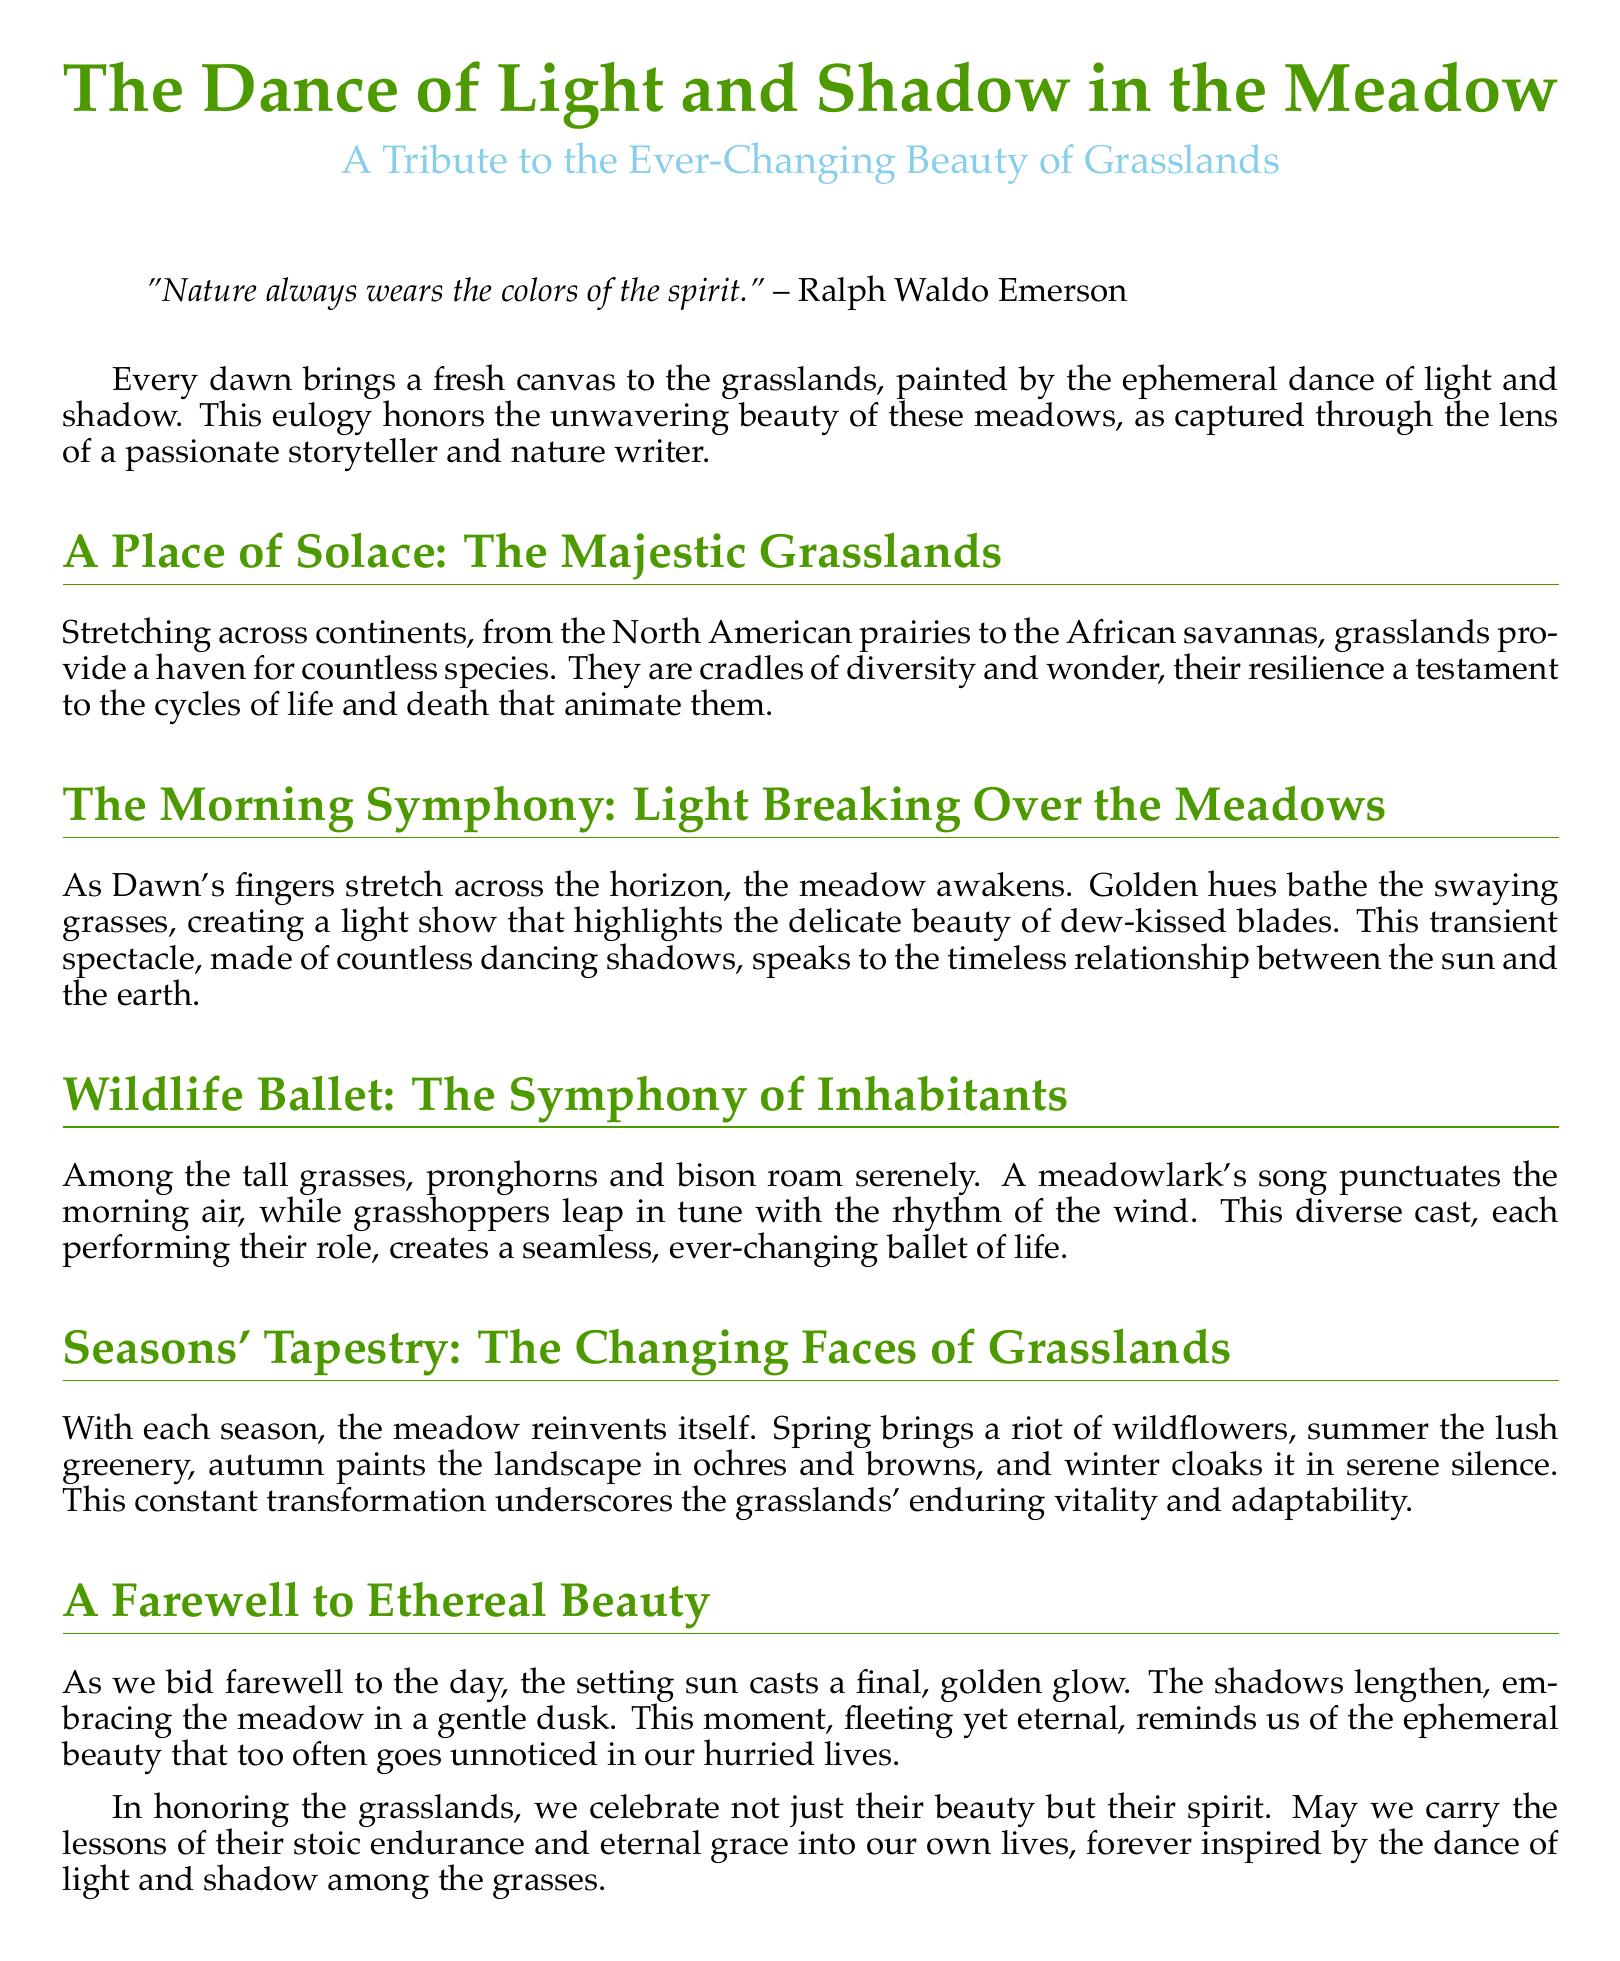What is the title of the document? The title is prominently displayed at the beginning of the document.
Answer: The Dance of Light and Shadow in the Meadow What is the subtitle of the document? The subtitle follows the title and provides further context.
Answer: A Tribute to the Ever-Changing Beauty of Grasslands Who is quoted at the beginning of the document? The quote includes the author's name alongside a profound statement about nature.
Answer: Ralph Waldo Emerson What natural phenomenon does the document describe at dawn? The document describes a specific time in relation to the meadow's beauty.
Answer: Light Breaking Over the Meadows Name one animal mentioned in the wildlife section. The document lists various inhabitants of the grasslands.
Answer: Pronghorns What do the seasons bring to the grasslands, according to the document? The document outlines how each season affects the meadow's appearance.
Answer: A riot of wildflowers What does the setting sun symbolize in the conclusion? The document reflects on the deeper meanings conveyed through the imagery of the sunset.
Answer: Ephemeral beauty What theme is emphasized in the farewell section? The document conveys a final message that encapsulates its central idea.
Answer: Stoic endurance and eternal grace 